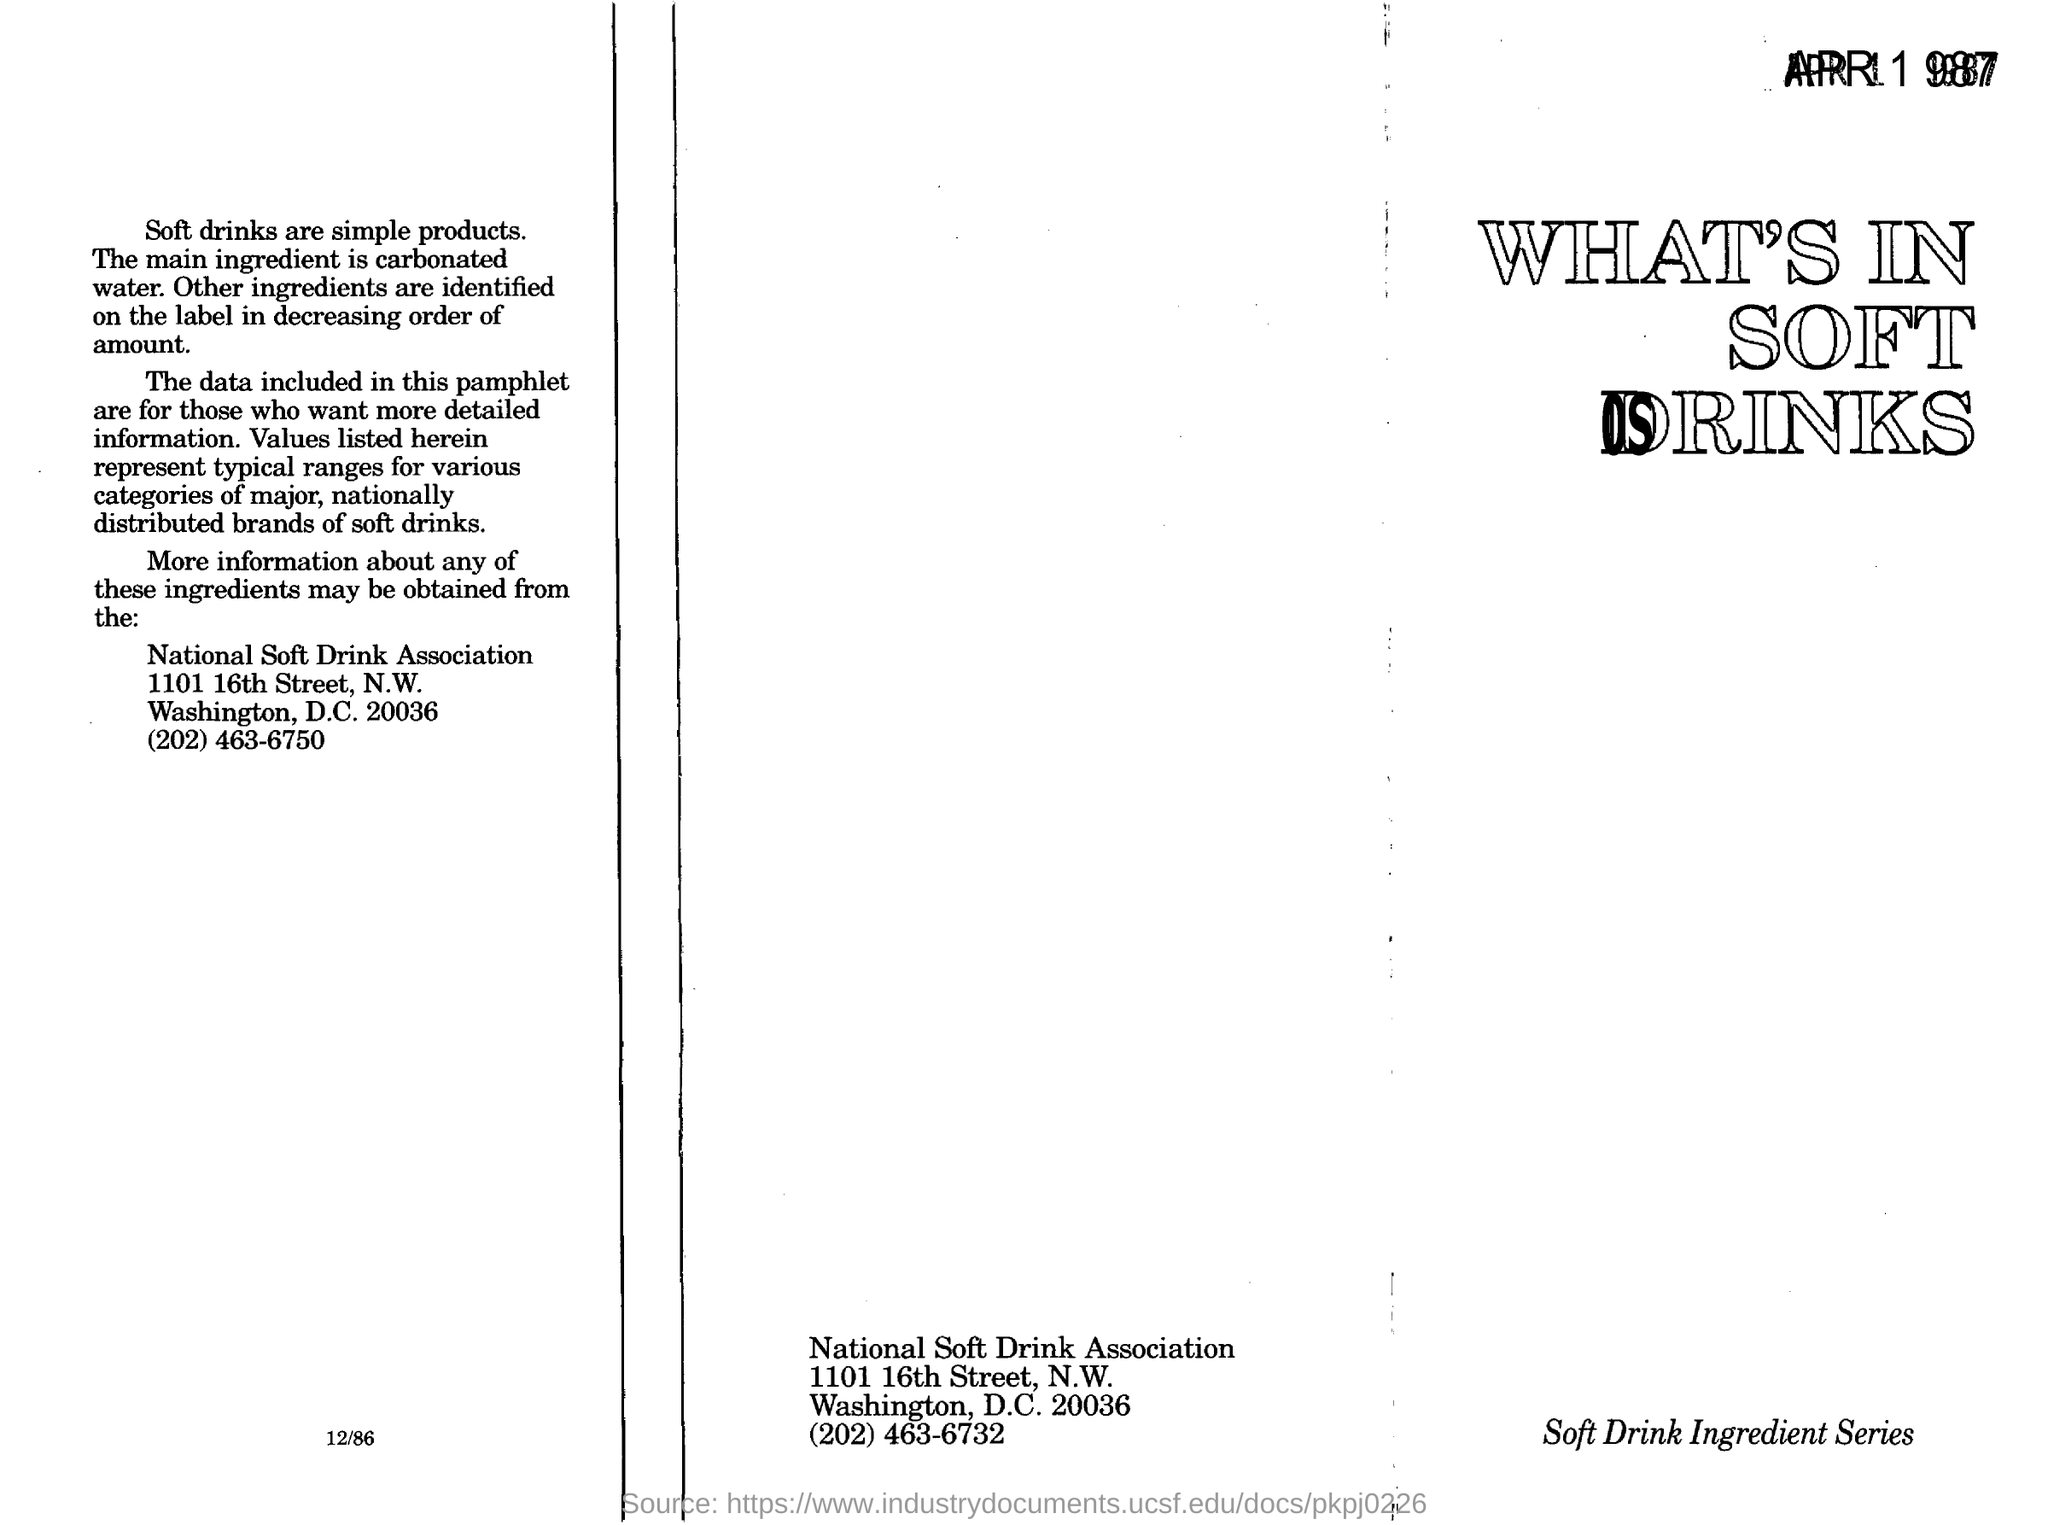What is the main ingredient of soft drink?
Offer a terse response. Carbonated water. What is the heading in right corner ?
Keep it short and to the point. WHAT'S IN SOFT DRINKS. 